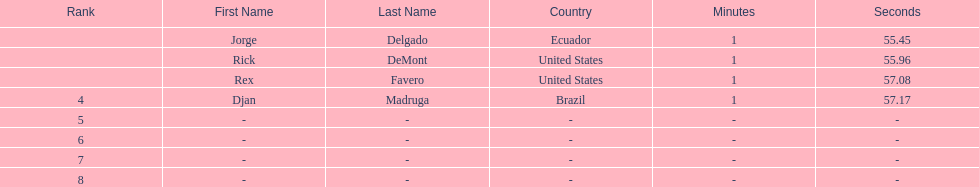Who was the last finisher from the us? Rex Favero. Could you parse the entire table as a dict? {'header': ['Rank', 'First Name', 'Last Name', 'Country', 'Minutes', 'Seconds'], 'rows': [['', 'Jorge', 'Delgado', 'Ecuador', '1', '55.45'], ['', 'Rick', 'DeMont', 'United States', '1', '55.96'], ['', 'Rex', 'Favero', 'United States', '1', '57.08'], ['4', 'Djan', 'Madruga', 'Brazil', '1', '57.17'], ['5', '-', '-', '-', '-', '-'], ['6', '-', '-', '-', '-', '-'], ['7', '-', '-', '-', '-', '-'], ['8', '-', '-', '-', '-', '-']]} 